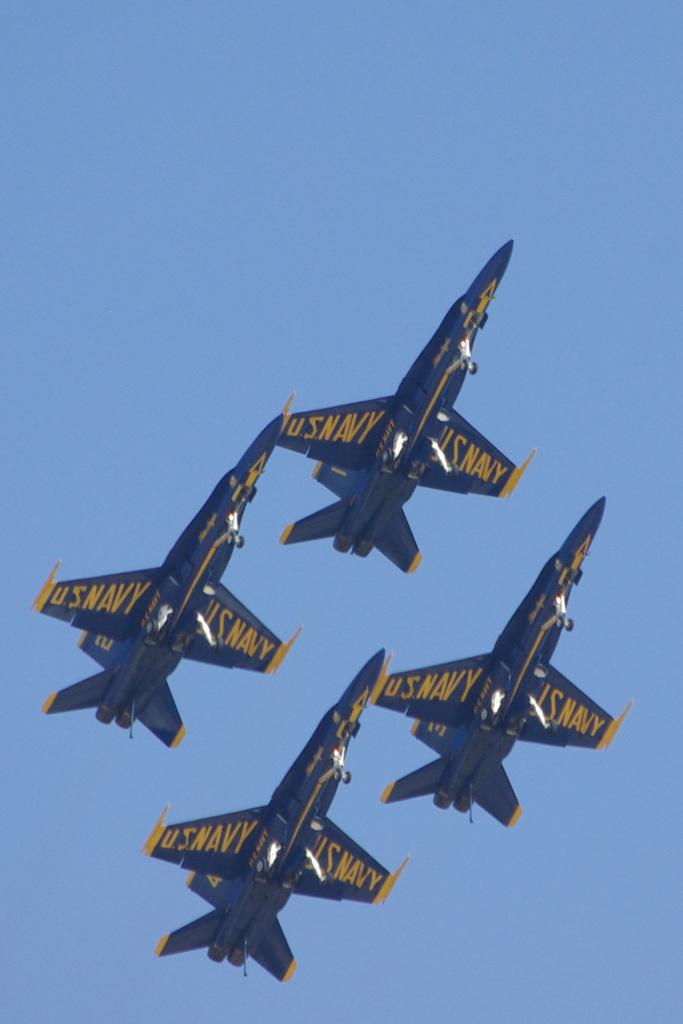How many aircrafts are present in the image? There are four aircrafts in the image. What colors are the aircrafts? The aircrafts are blue and yellow in color. Are there any markings or words on the aircrafts? Yes, there are words written on the aircrafts. What can be seen in the background of the image? The sky is blue in the background of the image. How does the police help the aircrafts in the image? There is no police presence in the image, and therefore no assistance can be observed. 